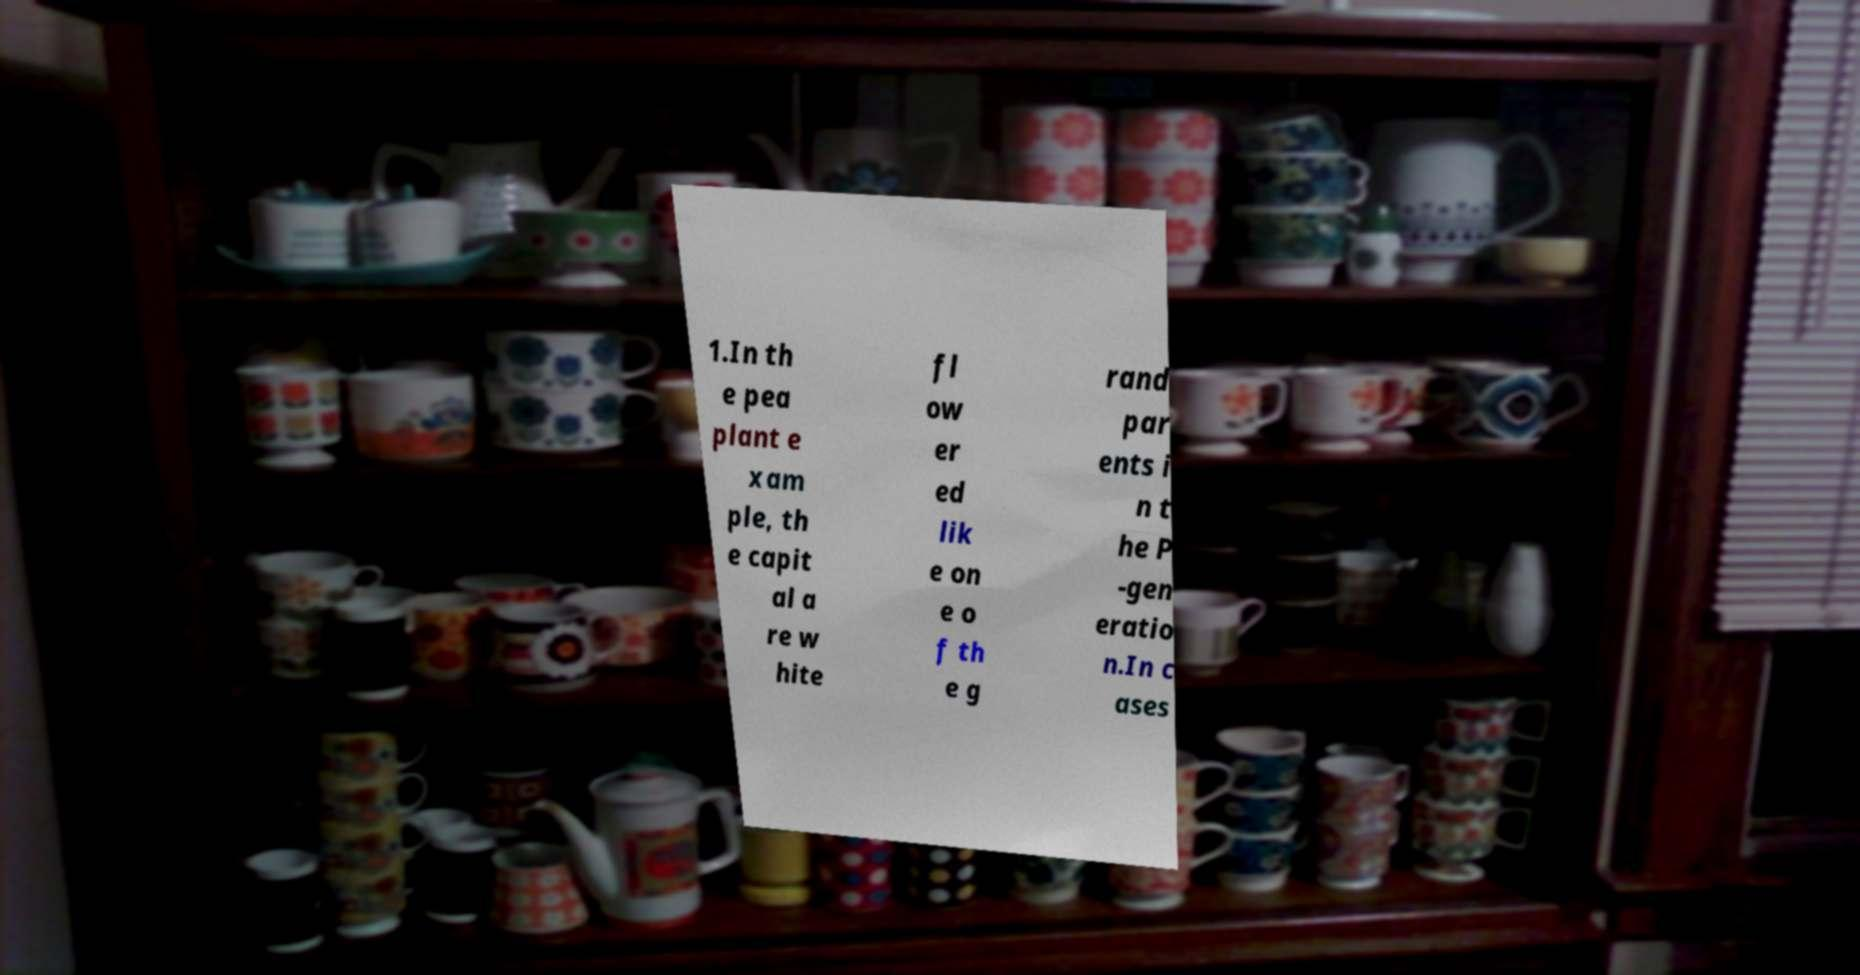Could you extract and type out the text from this image? 1.In th e pea plant e xam ple, th e capit al a re w hite fl ow er ed lik e on e o f th e g rand par ents i n t he P -gen eratio n.In c ases 